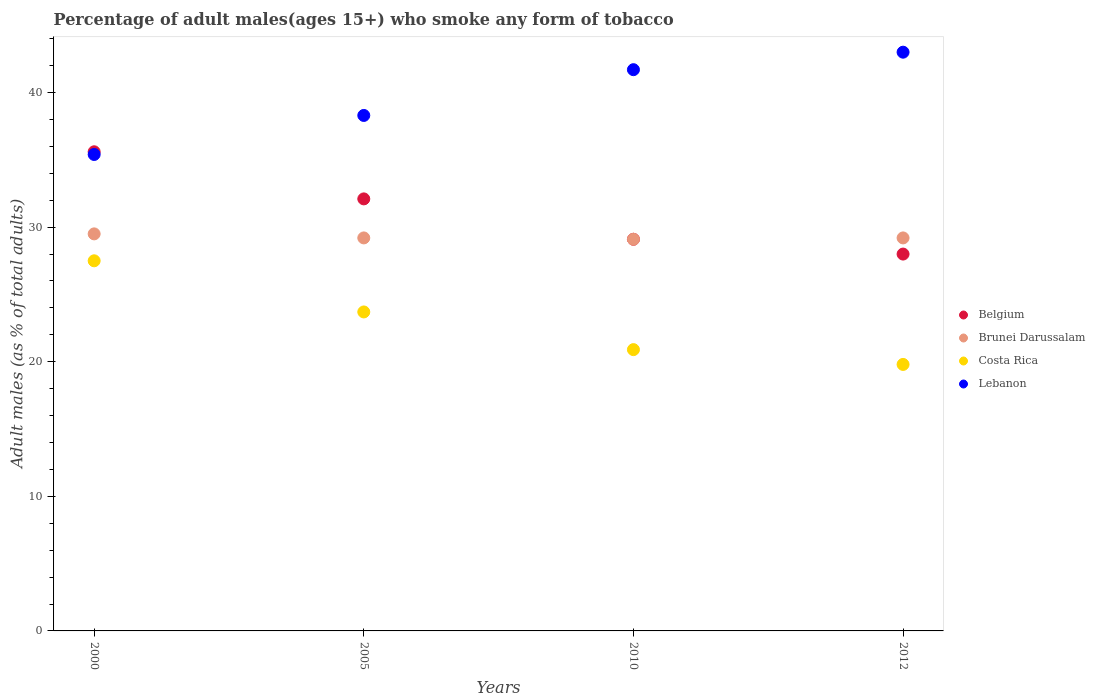How many different coloured dotlines are there?
Provide a short and direct response. 4. What is the percentage of adult males who smoke in Brunei Darussalam in 2010?
Offer a very short reply. 29.1. Across all years, what is the maximum percentage of adult males who smoke in Costa Rica?
Keep it short and to the point. 27.5. In which year was the percentage of adult males who smoke in Costa Rica maximum?
Keep it short and to the point. 2000. What is the total percentage of adult males who smoke in Brunei Darussalam in the graph?
Keep it short and to the point. 117. What is the difference between the percentage of adult males who smoke in Lebanon in 2000 and that in 2010?
Ensure brevity in your answer.  -6.3. What is the difference between the percentage of adult males who smoke in Lebanon in 2010 and the percentage of adult males who smoke in Belgium in 2012?
Offer a terse response. 13.7. What is the average percentage of adult males who smoke in Belgium per year?
Give a very brief answer. 31.2. In the year 2000, what is the difference between the percentage of adult males who smoke in Costa Rica and percentage of adult males who smoke in Lebanon?
Your answer should be compact. -7.9. What is the ratio of the percentage of adult males who smoke in Lebanon in 2005 to that in 2012?
Provide a short and direct response. 0.89. What is the difference between the highest and the second highest percentage of adult males who smoke in Belgium?
Offer a very short reply. 3.5. What is the difference between the highest and the lowest percentage of adult males who smoke in Lebanon?
Your answer should be very brief. 7.6. Is the sum of the percentage of adult males who smoke in Brunei Darussalam in 2000 and 2010 greater than the maximum percentage of adult males who smoke in Belgium across all years?
Your answer should be very brief. Yes. Is it the case that in every year, the sum of the percentage of adult males who smoke in Belgium and percentage of adult males who smoke in Brunei Darussalam  is greater than the sum of percentage of adult males who smoke in Lebanon and percentage of adult males who smoke in Costa Rica?
Provide a short and direct response. No. Does the percentage of adult males who smoke in Belgium monotonically increase over the years?
Keep it short and to the point. No. Is the percentage of adult males who smoke in Belgium strictly less than the percentage of adult males who smoke in Brunei Darussalam over the years?
Offer a terse response. No. How many years are there in the graph?
Keep it short and to the point. 4. Does the graph contain grids?
Your answer should be compact. No. What is the title of the graph?
Offer a terse response. Percentage of adult males(ages 15+) who smoke any form of tobacco. Does "Iceland" appear as one of the legend labels in the graph?
Offer a terse response. No. What is the label or title of the X-axis?
Keep it short and to the point. Years. What is the label or title of the Y-axis?
Ensure brevity in your answer.  Adult males (as % of total adults). What is the Adult males (as % of total adults) of Belgium in 2000?
Keep it short and to the point. 35.6. What is the Adult males (as % of total adults) of Brunei Darussalam in 2000?
Your answer should be compact. 29.5. What is the Adult males (as % of total adults) in Costa Rica in 2000?
Provide a succinct answer. 27.5. What is the Adult males (as % of total adults) of Lebanon in 2000?
Offer a terse response. 35.4. What is the Adult males (as % of total adults) in Belgium in 2005?
Your answer should be very brief. 32.1. What is the Adult males (as % of total adults) of Brunei Darussalam in 2005?
Make the answer very short. 29.2. What is the Adult males (as % of total adults) of Costa Rica in 2005?
Keep it short and to the point. 23.7. What is the Adult males (as % of total adults) in Lebanon in 2005?
Offer a terse response. 38.3. What is the Adult males (as % of total adults) in Belgium in 2010?
Ensure brevity in your answer.  29.1. What is the Adult males (as % of total adults) of Brunei Darussalam in 2010?
Offer a very short reply. 29.1. What is the Adult males (as % of total adults) in Costa Rica in 2010?
Your answer should be compact. 20.9. What is the Adult males (as % of total adults) of Lebanon in 2010?
Provide a succinct answer. 41.7. What is the Adult males (as % of total adults) of Brunei Darussalam in 2012?
Give a very brief answer. 29.2. What is the Adult males (as % of total adults) in Costa Rica in 2012?
Your answer should be compact. 19.8. Across all years, what is the maximum Adult males (as % of total adults) in Belgium?
Provide a short and direct response. 35.6. Across all years, what is the maximum Adult males (as % of total adults) in Brunei Darussalam?
Your answer should be very brief. 29.5. Across all years, what is the maximum Adult males (as % of total adults) in Costa Rica?
Offer a terse response. 27.5. Across all years, what is the minimum Adult males (as % of total adults) of Belgium?
Keep it short and to the point. 28. Across all years, what is the minimum Adult males (as % of total adults) in Brunei Darussalam?
Provide a short and direct response. 29.1. Across all years, what is the minimum Adult males (as % of total adults) of Costa Rica?
Your answer should be compact. 19.8. Across all years, what is the minimum Adult males (as % of total adults) of Lebanon?
Offer a terse response. 35.4. What is the total Adult males (as % of total adults) in Belgium in the graph?
Make the answer very short. 124.8. What is the total Adult males (as % of total adults) of Brunei Darussalam in the graph?
Your answer should be compact. 117. What is the total Adult males (as % of total adults) in Costa Rica in the graph?
Provide a short and direct response. 91.9. What is the total Adult males (as % of total adults) of Lebanon in the graph?
Your answer should be compact. 158.4. What is the difference between the Adult males (as % of total adults) of Lebanon in 2000 and that in 2005?
Offer a very short reply. -2.9. What is the difference between the Adult males (as % of total adults) in Costa Rica in 2000 and that in 2010?
Keep it short and to the point. 6.6. What is the difference between the Adult males (as % of total adults) in Belgium in 2000 and that in 2012?
Make the answer very short. 7.6. What is the difference between the Adult males (as % of total adults) of Costa Rica in 2000 and that in 2012?
Your answer should be very brief. 7.7. What is the difference between the Adult males (as % of total adults) of Belgium in 2005 and that in 2010?
Make the answer very short. 3. What is the difference between the Adult males (as % of total adults) of Brunei Darussalam in 2005 and that in 2010?
Your answer should be compact. 0.1. What is the difference between the Adult males (as % of total adults) of Costa Rica in 2005 and that in 2010?
Provide a short and direct response. 2.8. What is the difference between the Adult males (as % of total adults) of Lebanon in 2005 and that in 2010?
Ensure brevity in your answer.  -3.4. What is the difference between the Adult males (as % of total adults) in Belgium in 2010 and that in 2012?
Give a very brief answer. 1.1. What is the difference between the Adult males (as % of total adults) of Brunei Darussalam in 2010 and that in 2012?
Provide a short and direct response. -0.1. What is the difference between the Adult males (as % of total adults) of Lebanon in 2010 and that in 2012?
Your answer should be compact. -1.3. What is the difference between the Adult males (as % of total adults) in Belgium in 2000 and the Adult males (as % of total adults) in Brunei Darussalam in 2005?
Your answer should be compact. 6.4. What is the difference between the Adult males (as % of total adults) in Belgium in 2000 and the Adult males (as % of total adults) in Costa Rica in 2005?
Your answer should be compact. 11.9. What is the difference between the Adult males (as % of total adults) in Brunei Darussalam in 2000 and the Adult males (as % of total adults) in Lebanon in 2005?
Offer a very short reply. -8.8. What is the difference between the Adult males (as % of total adults) in Costa Rica in 2000 and the Adult males (as % of total adults) in Lebanon in 2005?
Offer a terse response. -10.8. What is the difference between the Adult males (as % of total adults) in Brunei Darussalam in 2000 and the Adult males (as % of total adults) in Costa Rica in 2010?
Your answer should be compact. 8.6. What is the difference between the Adult males (as % of total adults) in Costa Rica in 2000 and the Adult males (as % of total adults) in Lebanon in 2010?
Provide a short and direct response. -14.2. What is the difference between the Adult males (as % of total adults) of Belgium in 2000 and the Adult males (as % of total adults) of Brunei Darussalam in 2012?
Give a very brief answer. 6.4. What is the difference between the Adult males (as % of total adults) in Brunei Darussalam in 2000 and the Adult males (as % of total adults) in Costa Rica in 2012?
Offer a very short reply. 9.7. What is the difference between the Adult males (as % of total adults) in Brunei Darussalam in 2000 and the Adult males (as % of total adults) in Lebanon in 2012?
Provide a short and direct response. -13.5. What is the difference between the Adult males (as % of total adults) in Costa Rica in 2000 and the Adult males (as % of total adults) in Lebanon in 2012?
Provide a succinct answer. -15.5. What is the difference between the Adult males (as % of total adults) in Belgium in 2005 and the Adult males (as % of total adults) in Brunei Darussalam in 2010?
Provide a succinct answer. 3. What is the difference between the Adult males (as % of total adults) of Brunei Darussalam in 2005 and the Adult males (as % of total adults) of Lebanon in 2010?
Provide a succinct answer. -12.5. What is the difference between the Adult males (as % of total adults) of Costa Rica in 2005 and the Adult males (as % of total adults) of Lebanon in 2010?
Your answer should be very brief. -18. What is the difference between the Adult males (as % of total adults) of Costa Rica in 2005 and the Adult males (as % of total adults) of Lebanon in 2012?
Your answer should be compact. -19.3. What is the difference between the Adult males (as % of total adults) of Brunei Darussalam in 2010 and the Adult males (as % of total adults) of Costa Rica in 2012?
Provide a short and direct response. 9.3. What is the difference between the Adult males (as % of total adults) in Brunei Darussalam in 2010 and the Adult males (as % of total adults) in Lebanon in 2012?
Your answer should be very brief. -13.9. What is the difference between the Adult males (as % of total adults) of Costa Rica in 2010 and the Adult males (as % of total adults) of Lebanon in 2012?
Offer a terse response. -22.1. What is the average Adult males (as % of total adults) in Belgium per year?
Your answer should be very brief. 31.2. What is the average Adult males (as % of total adults) of Brunei Darussalam per year?
Your answer should be very brief. 29.25. What is the average Adult males (as % of total adults) in Costa Rica per year?
Your answer should be compact. 22.98. What is the average Adult males (as % of total adults) of Lebanon per year?
Your answer should be compact. 39.6. In the year 2000, what is the difference between the Adult males (as % of total adults) of Belgium and Adult males (as % of total adults) of Brunei Darussalam?
Keep it short and to the point. 6.1. In the year 2000, what is the difference between the Adult males (as % of total adults) in Belgium and Adult males (as % of total adults) in Lebanon?
Your response must be concise. 0.2. In the year 2000, what is the difference between the Adult males (as % of total adults) in Brunei Darussalam and Adult males (as % of total adults) in Lebanon?
Ensure brevity in your answer.  -5.9. In the year 2005, what is the difference between the Adult males (as % of total adults) in Belgium and Adult males (as % of total adults) in Brunei Darussalam?
Give a very brief answer. 2.9. In the year 2005, what is the difference between the Adult males (as % of total adults) in Belgium and Adult males (as % of total adults) in Costa Rica?
Ensure brevity in your answer.  8.4. In the year 2005, what is the difference between the Adult males (as % of total adults) of Belgium and Adult males (as % of total adults) of Lebanon?
Your response must be concise. -6.2. In the year 2005, what is the difference between the Adult males (as % of total adults) in Costa Rica and Adult males (as % of total adults) in Lebanon?
Offer a very short reply. -14.6. In the year 2010, what is the difference between the Adult males (as % of total adults) of Belgium and Adult males (as % of total adults) of Lebanon?
Make the answer very short. -12.6. In the year 2010, what is the difference between the Adult males (as % of total adults) of Brunei Darussalam and Adult males (as % of total adults) of Costa Rica?
Provide a succinct answer. 8.2. In the year 2010, what is the difference between the Adult males (as % of total adults) in Costa Rica and Adult males (as % of total adults) in Lebanon?
Your answer should be compact. -20.8. In the year 2012, what is the difference between the Adult males (as % of total adults) of Brunei Darussalam and Adult males (as % of total adults) of Costa Rica?
Your response must be concise. 9.4. In the year 2012, what is the difference between the Adult males (as % of total adults) in Brunei Darussalam and Adult males (as % of total adults) in Lebanon?
Give a very brief answer. -13.8. In the year 2012, what is the difference between the Adult males (as % of total adults) of Costa Rica and Adult males (as % of total adults) of Lebanon?
Give a very brief answer. -23.2. What is the ratio of the Adult males (as % of total adults) in Belgium in 2000 to that in 2005?
Offer a very short reply. 1.11. What is the ratio of the Adult males (as % of total adults) in Brunei Darussalam in 2000 to that in 2005?
Give a very brief answer. 1.01. What is the ratio of the Adult males (as % of total adults) in Costa Rica in 2000 to that in 2005?
Your response must be concise. 1.16. What is the ratio of the Adult males (as % of total adults) in Lebanon in 2000 to that in 2005?
Provide a short and direct response. 0.92. What is the ratio of the Adult males (as % of total adults) in Belgium in 2000 to that in 2010?
Your response must be concise. 1.22. What is the ratio of the Adult males (as % of total adults) of Brunei Darussalam in 2000 to that in 2010?
Give a very brief answer. 1.01. What is the ratio of the Adult males (as % of total adults) of Costa Rica in 2000 to that in 2010?
Your answer should be very brief. 1.32. What is the ratio of the Adult males (as % of total adults) of Lebanon in 2000 to that in 2010?
Offer a very short reply. 0.85. What is the ratio of the Adult males (as % of total adults) in Belgium in 2000 to that in 2012?
Keep it short and to the point. 1.27. What is the ratio of the Adult males (as % of total adults) of Brunei Darussalam in 2000 to that in 2012?
Give a very brief answer. 1.01. What is the ratio of the Adult males (as % of total adults) in Costa Rica in 2000 to that in 2012?
Offer a terse response. 1.39. What is the ratio of the Adult males (as % of total adults) of Lebanon in 2000 to that in 2012?
Your answer should be very brief. 0.82. What is the ratio of the Adult males (as % of total adults) in Belgium in 2005 to that in 2010?
Keep it short and to the point. 1.1. What is the ratio of the Adult males (as % of total adults) in Brunei Darussalam in 2005 to that in 2010?
Ensure brevity in your answer.  1. What is the ratio of the Adult males (as % of total adults) of Costa Rica in 2005 to that in 2010?
Your response must be concise. 1.13. What is the ratio of the Adult males (as % of total adults) in Lebanon in 2005 to that in 2010?
Offer a terse response. 0.92. What is the ratio of the Adult males (as % of total adults) in Belgium in 2005 to that in 2012?
Offer a very short reply. 1.15. What is the ratio of the Adult males (as % of total adults) in Costa Rica in 2005 to that in 2012?
Provide a succinct answer. 1.2. What is the ratio of the Adult males (as % of total adults) in Lebanon in 2005 to that in 2012?
Your answer should be compact. 0.89. What is the ratio of the Adult males (as % of total adults) in Belgium in 2010 to that in 2012?
Your response must be concise. 1.04. What is the ratio of the Adult males (as % of total adults) in Brunei Darussalam in 2010 to that in 2012?
Make the answer very short. 1. What is the ratio of the Adult males (as % of total adults) in Costa Rica in 2010 to that in 2012?
Provide a short and direct response. 1.06. What is the ratio of the Adult males (as % of total adults) of Lebanon in 2010 to that in 2012?
Your response must be concise. 0.97. What is the difference between the highest and the second highest Adult males (as % of total adults) in Belgium?
Provide a short and direct response. 3.5. What is the difference between the highest and the second highest Adult males (as % of total adults) of Costa Rica?
Offer a very short reply. 3.8. What is the difference between the highest and the lowest Adult males (as % of total adults) in Belgium?
Ensure brevity in your answer.  7.6. What is the difference between the highest and the lowest Adult males (as % of total adults) in Costa Rica?
Your answer should be compact. 7.7. 